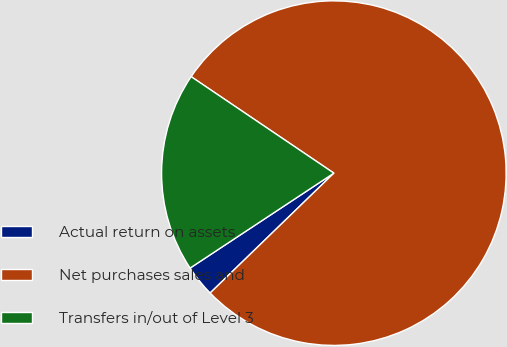Convert chart to OTSL. <chart><loc_0><loc_0><loc_500><loc_500><pie_chart><fcel>Actual return on assets<fcel>Net purchases sales and<fcel>Transfers in/out of Level 3<nl><fcel>2.96%<fcel>78.29%<fcel>18.75%<nl></chart> 